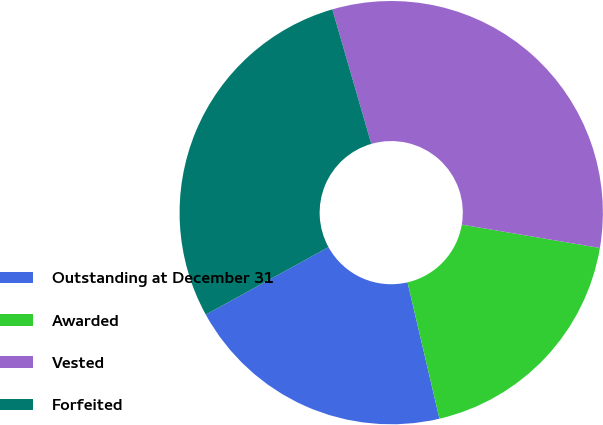Convert chart to OTSL. <chart><loc_0><loc_0><loc_500><loc_500><pie_chart><fcel>Outstanding at December 31<fcel>Awarded<fcel>Vested<fcel>Forfeited<nl><fcel>20.66%<fcel>18.67%<fcel>32.16%<fcel>28.51%<nl></chart> 